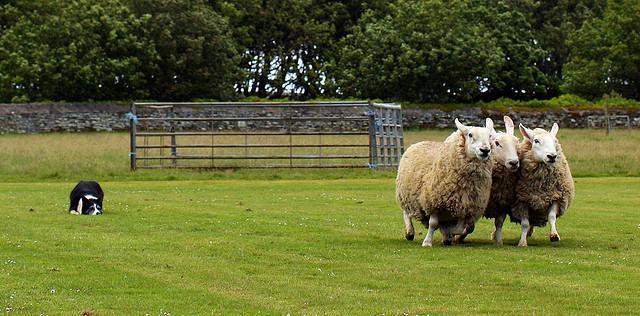How many sheep are there?
Give a very brief answer. 3. How many sheep are in the photo?
Give a very brief answer. 3. How many toothbrushes are pictured?
Give a very brief answer. 0. 